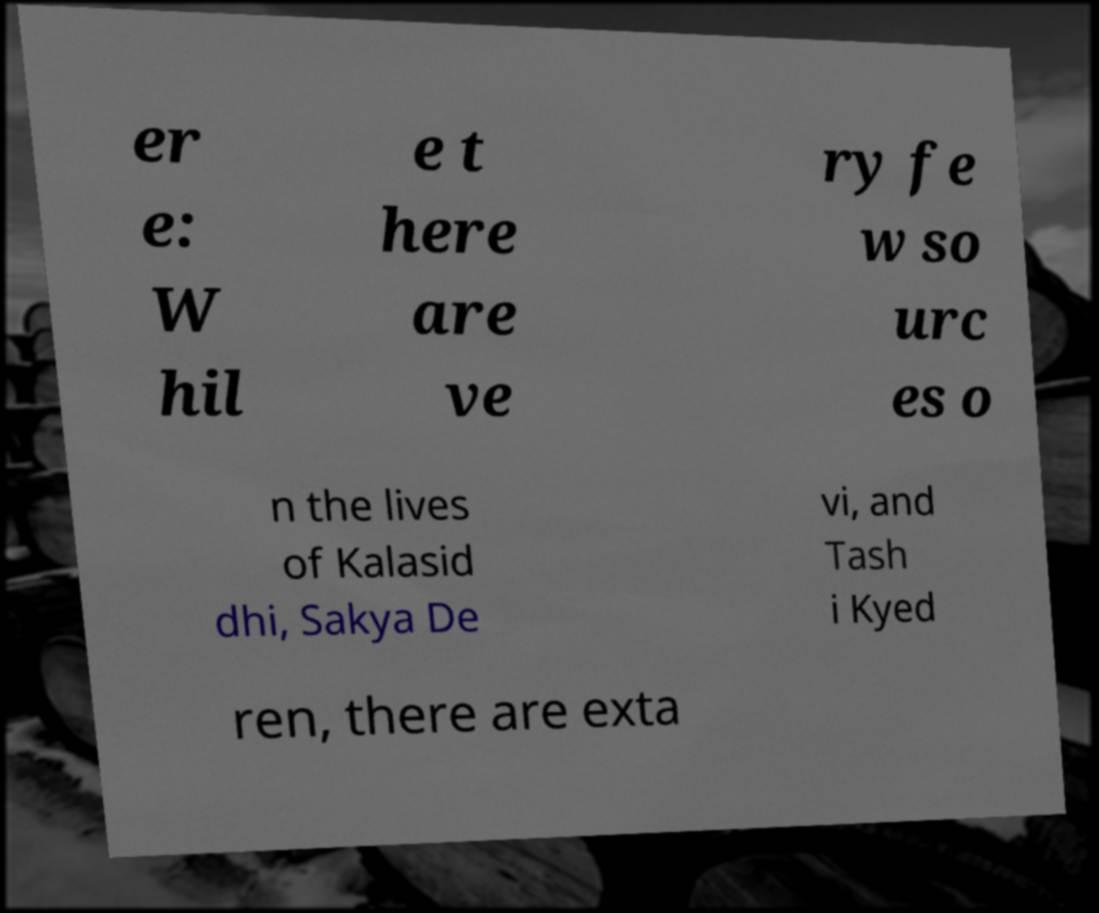Can you read and provide the text displayed in the image?This photo seems to have some interesting text. Can you extract and type it out for me? er e: W hil e t here are ve ry fe w so urc es o n the lives of Kalasid dhi, Sakya De vi, and Tash i Kyed ren, there are exta 